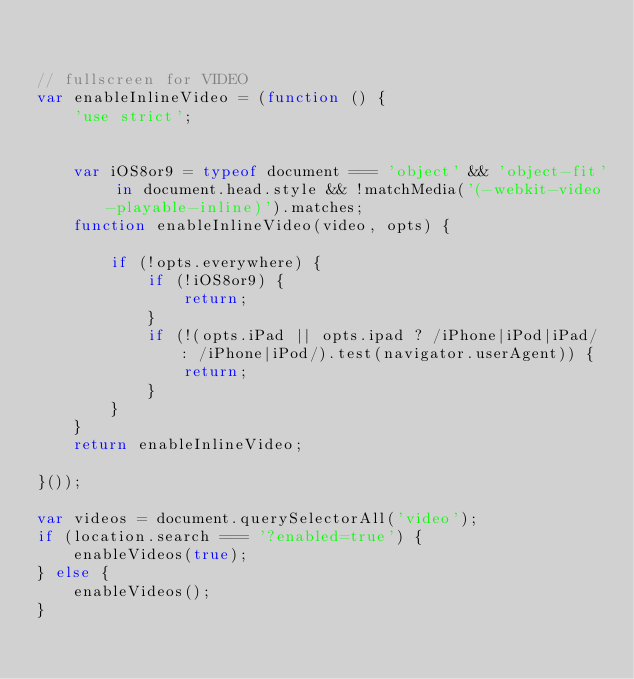<code> <loc_0><loc_0><loc_500><loc_500><_JavaScript_>

// fullscreen for VIDEO
var enableInlineVideo = (function () {
	'use strict';


	var iOS8or9 = typeof document === 'object' && 'object-fit' in document.head.style && !matchMedia('(-webkit-video-playable-inline)').matches;
	function enableInlineVideo(video, opts) {

		if (!opts.everywhere) {
			if (!iOS8or9) {
				return;
			}
			if (!(opts.iPad || opts.ipad ? /iPhone|iPod|iPad/ : /iPhone|iPod/).test(navigator.userAgent)) {
				return;
			}
		}
	}
	return enableInlineVideo;

}());

var videos = document.querySelectorAll('video');
if (location.search === '?enabled=true') {
	enableVideos(true);
} else {
	enableVideos();
}
</code> 